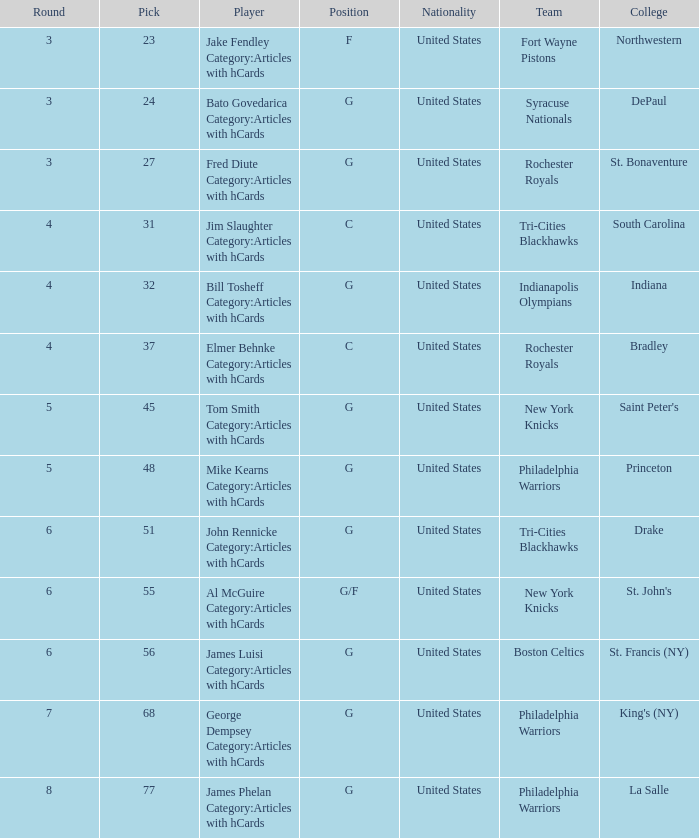What is the lowest pick number for players from king's (ny)? 68.0. 